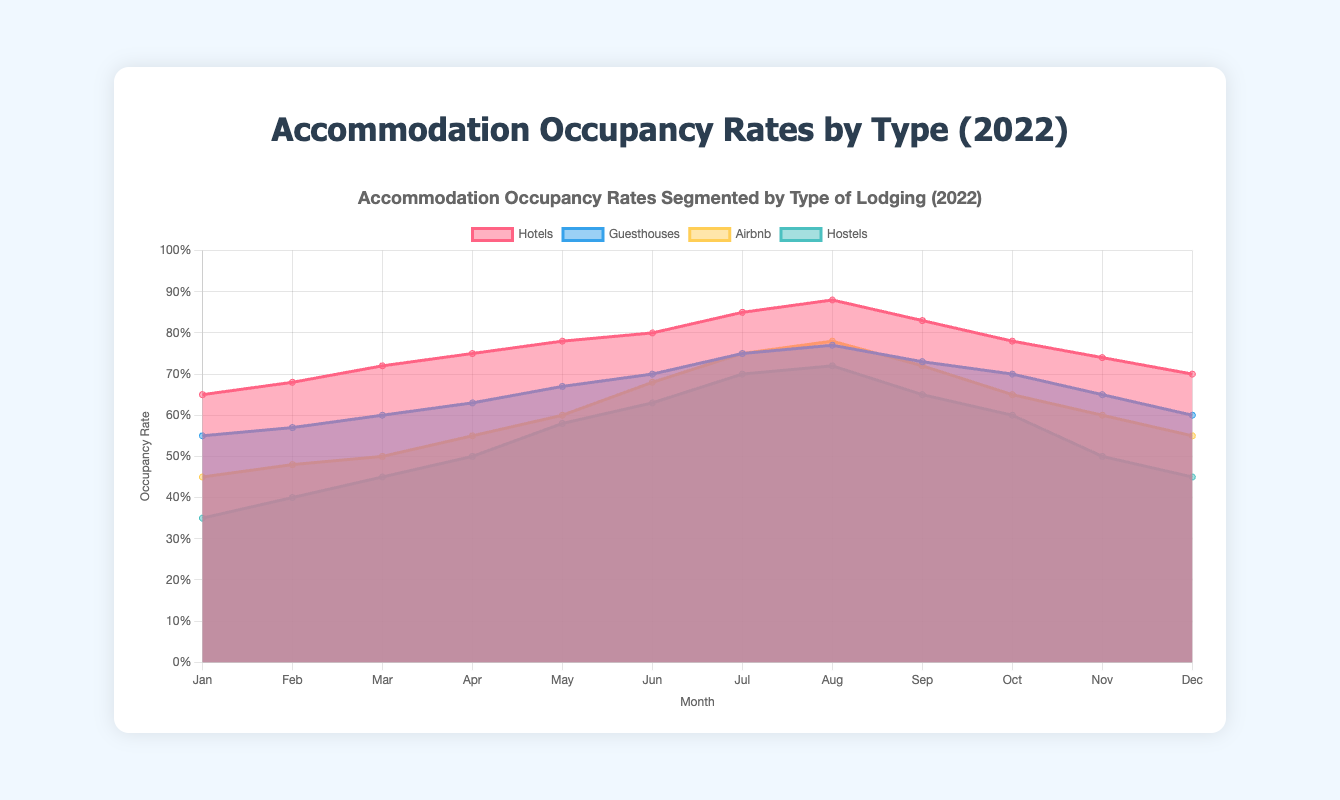What is the title of the figure? The title of the figure is displayed prominently at the top. It reads "Accommodation Occupancy Rates Segmented by Type of Lodging (2022)"
Answer: Accommodation Occupancy Rates Segmented by Type of Lodging (2022) How many types of lodging are represented in the chart? The chart consists of four differently colored areas corresponding to four types of lodging, as indicated by the legend: Hotels, Guesthouses, Airbnb, and Hostels.
Answer: 4 Which type of lodging had the highest occupancy rate in August? By examining the area chart for August, the highest section belongs to Hotels.
Answer: Hotels What is the occupancy trend for Hostels throughout the year? The line for Hostels starts at 0.35 in January, increases steadily peaking at 0.72 in August, then declines back to 0.45 by December.
Answer: Increasing till August then decreasing Which month had the highest overall occupancy rate for all accommodation types? In the chart, find the month where the sum of all areas is the highest. August shows the highest peaks across all accommodation types.
Answer: August How does the occupancy rate of Airbnb in June compare to November? From the data in the chart, Airbnb's occupancy rate is about 0.68 in June and drops to 0.60 in November.
Answer: Higher in June What is the difference in occupancy rates between Hotels and Guesthouses in December? Hotels have an occupancy rate of 0.70, while Guesthouses have 0.60 in December. The difference is 0.70 - 0.60 = 0.10.
Answer: 0.10 Which type of lodging experienced the greatest increase in occupancy rate from January to July? The chart shows that Airbnb increased from 0.45 in January to 0.75 in July, which is an increase of 0.75 - 0.45 = 0.30. The other types have smaller increases.
Answer: Airbnb During which months did Guesthouses and Airbnb have equal occupancy rates? By inspecting the overlapping areas for equality, both Guesthouses and Airbnb have occupancy rates of 0.77 in August.
Answer: August 